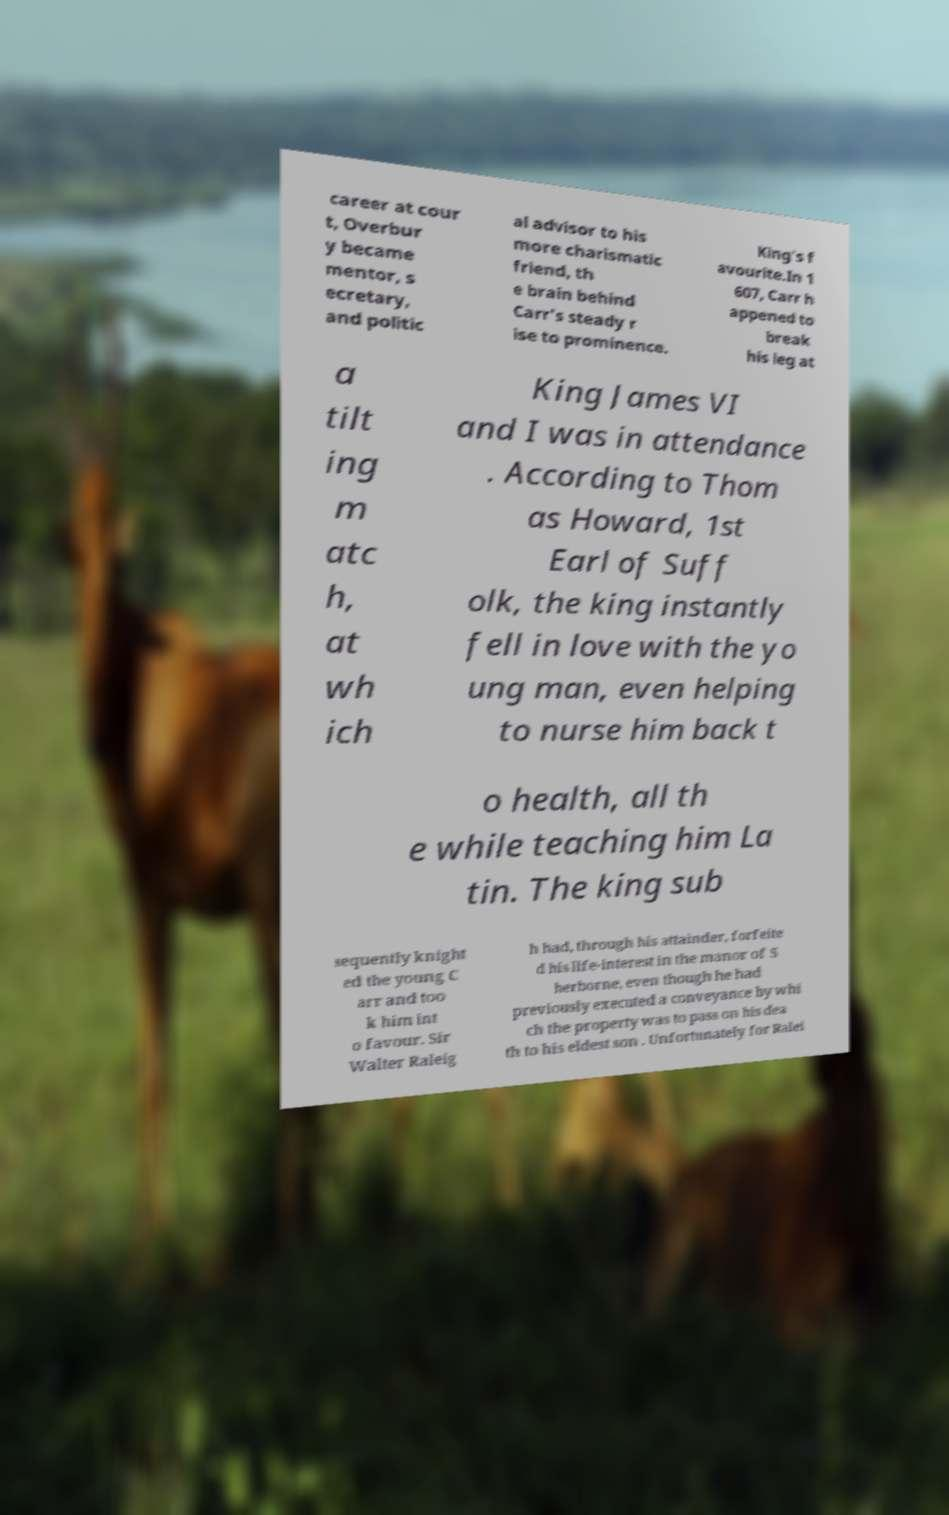Please read and relay the text visible in this image. What does it say? career at cour t, Overbur y became mentor, s ecretary, and politic al advisor to his more charismatic friend, th e brain behind Carr's steady r ise to prominence. King's f avourite.In 1 607, Carr h appened to break his leg at a tilt ing m atc h, at wh ich King James VI and I was in attendance . According to Thom as Howard, 1st Earl of Suff olk, the king instantly fell in love with the yo ung man, even helping to nurse him back t o health, all th e while teaching him La tin. The king sub sequently knight ed the young C arr and too k him int o favour. Sir Walter Raleig h had, through his attainder, forfeite d his life-interest in the manor of S herborne, even though he had previously executed a conveyance by whi ch the property was to pass on his dea th to his eldest son . Unfortunately for Ralei 